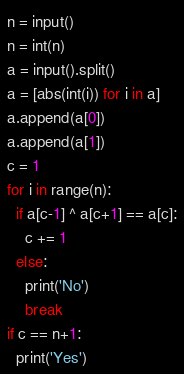<code> <loc_0><loc_0><loc_500><loc_500><_Python_>n = input()
n = int(n)
a = input().split()
a = [abs(int(i)) for i in a]
a.append(a[0])
a.append(a[1])
c = 1
for i in range(n):
  if a[c-1] ^ a[c+1] == a[c]:
    c += 1
  else: 
    print('No')
    break
if c == n+1:
  print('Yes')
</code> 